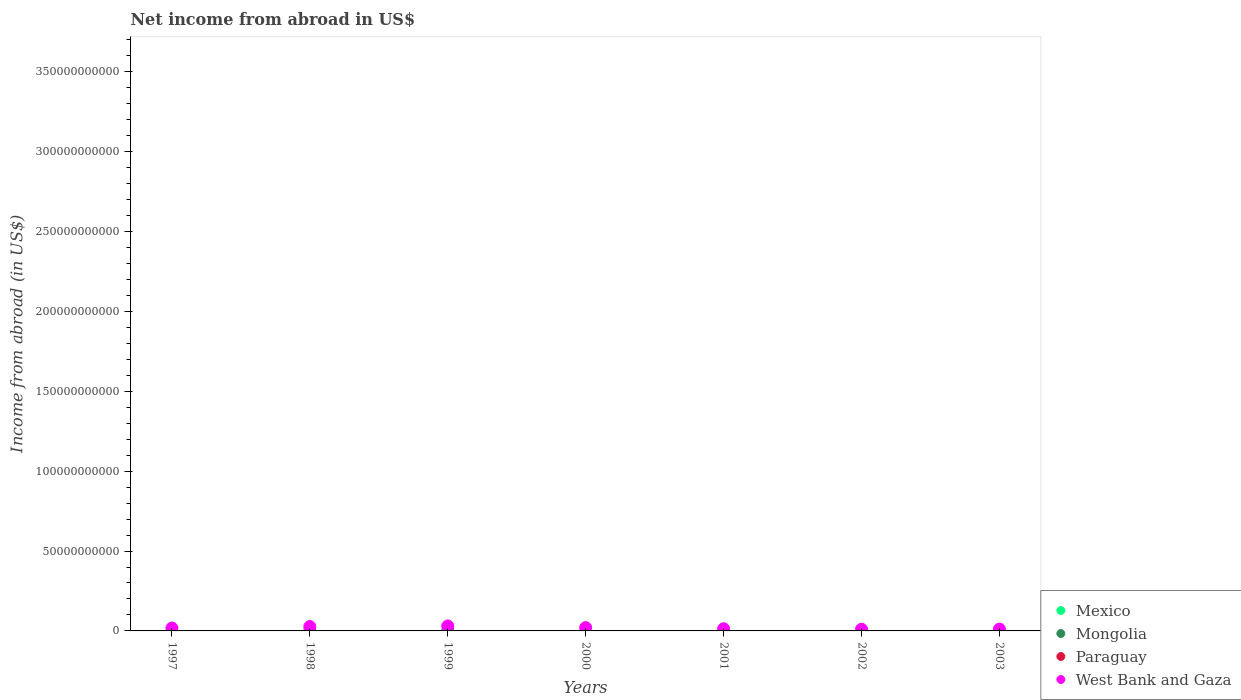What is the net income from abroad in Mexico in 1997?
Ensure brevity in your answer.  0. Across all years, what is the maximum net income from abroad in West Bank and Gaza?
Give a very brief answer. 3.12e+09. Across all years, what is the minimum net income from abroad in West Bank and Gaza?
Give a very brief answer. 1.04e+09. What is the total net income from abroad in Paraguay in the graph?
Keep it short and to the point. 0. What is the difference between the net income from abroad in West Bank and Gaza in 1998 and that in 2000?
Make the answer very short. 6.69e+08. What is the difference between the net income from abroad in West Bank and Gaza in 1999 and the net income from abroad in Mexico in 2000?
Offer a terse response. 3.12e+09. In the year 1998, what is the difference between the net income from abroad in Mongolia and net income from abroad in West Bank and Gaza?
Make the answer very short. -2.40e+09. In how many years, is the net income from abroad in West Bank and Gaza greater than 230000000000 US$?
Keep it short and to the point. 0. What is the ratio of the net income from abroad in West Bank and Gaza in 1997 to that in 2003?
Make the answer very short. 1.62. Is the net income from abroad in West Bank and Gaza in 1999 less than that in 2003?
Make the answer very short. No. What is the difference between the highest and the second highest net income from abroad in West Bank and Gaza?
Offer a very short reply. 3.90e+08. What is the difference between the highest and the lowest net income from abroad in West Bank and Gaza?
Provide a short and direct response. 2.08e+09. Is it the case that in every year, the sum of the net income from abroad in West Bank and Gaza and net income from abroad in Mexico  is greater than the sum of net income from abroad in Paraguay and net income from abroad in Mongolia?
Your answer should be compact. No. Is it the case that in every year, the sum of the net income from abroad in West Bank and Gaza and net income from abroad in Mexico  is greater than the net income from abroad in Mongolia?
Keep it short and to the point. Yes. Does the net income from abroad in Paraguay monotonically increase over the years?
Keep it short and to the point. No. Is the net income from abroad in Paraguay strictly greater than the net income from abroad in West Bank and Gaza over the years?
Your answer should be compact. No. What is the difference between two consecutive major ticks on the Y-axis?
Ensure brevity in your answer.  5.00e+1. Are the values on the major ticks of Y-axis written in scientific E-notation?
Your answer should be very brief. No. Does the graph contain any zero values?
Provide a succinct answer. Yes. Where does the legend appear in the graph?
Offer a very short reply. Bottom right. How many legend labels are there?
Keep it short and to the point. 4. How are the legend labels stacked?
Provide a succinct answer. Vertical. What is the title of the graph?
Ensure brevity in your answer.  Net income from abroad in US$. What is the label or title of the Y-axis?
Offer a terse response. Income from abroad (in US$). What is the Income from abroad (in US$) in Mongolia in 1997?
Keep it short and to the point. 0. What is the Income from abroad (in US$) of West Bank and Gaza in 1997?
Give a very brief answer. 1.80e+09. What is the Income from abroad (in US$) of Mexico in 1998?
Your answer should be compact. 0. What is the Income from abroad (in US$) in Mongolia in 1998?
Provide a short and direct response. 3.36e+08. What is the Income from abroad (in US$) in Paraguay in 1998?
Give a very brief answer. 0. What is the Income from abroad (in US$) of West Bank and Gaza in 1998?
Your answer should be very brief. 2.73e+09. What is the Income from abroad (in US$) of Mexico in 1999?
Provide a succinct answer. 0. What is the Income from abroad (in US$) of Mongolia in 1999?
Your response must be concise. 1.02e+08. What is the Income from abroad (in US$) in Paraguay in 1999?
Ensure brevity in your answer.  0. What is the Income from abroad (in US$) of West Bank and Gaza in 1999?
Provide a short and direct response. 3.12e+09. What is the Income from abroad (in US$) in Mexico in 2000?
Your answer should be very brief. 0. What is the Income from abroad (in US$) of Mongolia in 2000?
Ensure brevity in your answer.  0. What is the Income from abroad (in US$) in West Bank and Gaza in 2000?
Your response must be concise. 2.06e+09. What is the Income from abroad (in US$) of Mexico in 2001?
Your answer should be compact. 0. What is the Income from abroad (in US$) of West Bank and Gaza in 2001?
Make the answer very short. 1.34e+09. What is the Income from abroad (in US$) in Mexico in 2002?
Offer a terse response. 0. What is the Income from abroad (in US$) of West Bank and Gaza in 2002?
Offer a very short reply. 1.04e+09. What is the Income from abroad (in US$) in Mexico in 2003?
Your response must be concise. 0. What is the Income from abroad (in US$) in Mongolia in 2003?
Your answer should be compact. 0. What is the Income from abroad (in US$) in Paraguay in 2003?
Provide a succinct answer. 0. What is the Income from abroad (in US$) of West Bank and Gaza in 2003?
Give a very brief answer. 1.11e+09. Across all years, what is the maximum Income from abroad (in US$) in Mongolia?
Ensure brevity in your answer.  3.36e+08. Across all years, what is the maximum Income from abroad (in US$) of West Bank and Gaza?
Your answer should be very brief. 3.12e+09. Across all years, what is the minimum Income from abroad (in US$) in Mongolia?
Offer a terse response. 0. Across all years, what is the minimum Income from abroad (in US$) of West Bank and Gaza?
Make the answer very short. 1.04e+09. What is the total Income from abroad (in US$) in Mongolia in the graph?
Provide a short and direct response. 4.38e+08. What is the total Income from abroad (in US$) in Paraguay in the graph?
Ensure brevity in your answer.  0. What is the total Income from abroad (in US$) in West Bank and Gaza in the graph?
Your answer should be compact. 1.32e+1. What is the difference between the Income from abroad (in US$) in West Bank and Gaza in 1997 and that in 1998?
Give a very brief answer. -9.36e+08. What is the difference between the Income from abroad (in US$) of West Bank and Gaza in 1997 and that in 1999?
Make the answer very short. -1.33e+09. What is the difference between the Income from abroad (in US$) in West Bank and Gaza in 1997 and that in 2000?
Offer a terse response. -2.67e+08. What is the difference between the Income from abroad (in US$) of West Bank and Gaza in 1997 and that in 2001?
Your answer should be compact. 4.52e+08. What is the difference between the Income from abroad (in US$) of West Bank and Gaza in 1997 and that in 2002?
Make the answer very short. 7.57e+08. What is the difference between the Income from abroad (in US$) of West Bank and Gaza in 1997 and that in 2003?
Offer a terse response. 6.84e+08. What is the difference between the Income from abroad (in US$) in Mongolia in 1998 and that in 1999?
Your response must be concise. 2.34e+08. What is the difference between the Income from abroad (in US$) of West Bank and Gaza in 1998 and that in 1999?
Your answer should be very brief. -3.90e+08. What is the difference between the Income from abroad (in US$) of West Bank and Gaza in 1998 and that in 2000?
Provide a succinct answer. 6.69e+08. What is the difference between the Income from abroad (in US$) in West Bank and Gaza in 1998 and that in 2001?
Make the answer very short. 1.39e+09. What is the difference between the Income from abroad (in US$) of West Bank and Gaza in 1998 and that in 2002?
Your response must be concise. 1.69e+09. What is the difference between the Income from abroad (in US$) in West Bank and Gaza in 1998 and that in 2003?
Provide a short and direct response. 1.62e+09. What is the difference between the Income from abroad (in US$) in West Bank and Gaza in 1999 and that in 2000?
Offer a terse response. 1.06e+09. What is the difference between the Income from abroad (in US$) in West Bank and Gaza in 1999 and that in 2001?
Offer a very short reply. 1.78e+09. What is the difference between the Income from abroad (in US$) in West Bank and Gaza in 1999 and that in 2002?
Your answer should be very brief. 2.08e+09. What is the difference between the Income from abroad (in US$) of West Bank and Gaza in 1999 and that in 2003?
Your answer should be very brief. 2.01e+09. What is the difference between the Income from abroad (in US$) in West Bank and Gaza in 2000 and that in 2001?
Your answer should be very brief. 7.19e+08. What is the difference between the Income from abroad (in US$) of West Bank and Gaza in 2000 and that in 2002?
Make the answer very short. 1.02e+09. What is the difference between the Income from abroad (in US$) of West Bank and Gaza in 2000 and that in 2003?
Give a very brief answer. 9.52e+08. What is the difference between the Income from abroad (in US$) in West Bank and Gaza in 2001 and that in 2002?
Your response must be concise. 3.05e+08. What is the difference between the Income from abroad (in US$) in West Bank and Gaza in 2001 and that in 2003?
Provide a succinct answer. 2.32e+08. What is the difference between the Income from abroad (in US$) in West Bank and Gaza in 2002 and that in 2003?
Offer a terse response. -7.34e+07. What is the difference between the Income from abroad (in US$) of Mongolia in 1998 and the Income from abroad (in US$) of West Bank and Gaza in 1999?
Provide a short and direct response. -2.78e+09. What is the difference between the Income from abroad (in US$) in Mongolia in 1998 and the Income from abroad (in US$) in West Bank and Gaza in 2000?
Your response must be concise. -1.73e+09. What is the difference between the Income from abroad (in US$) in Mongolia in 1998 and the Income from abroad (in US$) in West Bank and Gaza in 2001?
Make the answer very short. -1.01e+09. What is the difference between the Income from abroad (in US$) of Mongolia in 1998 and the Income from abroad (in US$) of West Bank and Gaza in 2002?
Your response must be concise. -7.02e+08. What is the difference between the Income from abroad (in US$) in Mongolia in 1998 and the Income from abroad (in US$) in West Bank and Gaza in 2003?
Make the answer very short. -7.75e+08. What is the difference between the Income from abroad (in US$) of Mongolia in 1999 and the Income from abroad (in US$) of West Bank and Gaza in 2000?
Your answer should be compact. -1.96e+09. What is the difference between the Income from abroad (in US$) of Mongolia in 1999 and the Income from abroad (in US$) of West Bank and Gaza in 2001?
Your answer should be compact. -1.24e+09. What is the difference between the Income from abroad (in US$) in Mongolia in 1999 and the Income from abroad (in US$) in West Bank and Gaza in 2002?
Give a very brief answer. -9.35e+08. What is the difference between the Income from abroad (in US$) in Mongolia in 1999 and the Income from abroad (in US$) in West Bank and Gaza in 2003?
Make the answer very short. -1.01e+09. What is the average Income from abroad (in US$) in Mexico per year?
Provide a short and direct response. 0. What is the average Income from abroad (in US$) of Mongolia per year?
Offer a terse response. 6.26e+07. What is the average Income from abroad (in US$) of Paraguay per year?
Make the answer very short. 0. What is the average Income from abroad (in US$) in West Bank and Gaza per year?
Provide a succinct answer. 1.89e+09. In the year 1998, what is the difference between the Income from abroad (in US$) in Mongolia and Income from abroad (in US$) in West Bank and Gaza?
Offer a very short reply. -2.40e+09. In the year 1999, what is the difference between the Income from abroad (in US$) in Mongolia and Income from abroad (in US$) in West Bank and Gaza?
Your response must be concise. -3.02e+09. What is the ratio of the Income from abroad (in US$) of West Bank and Gaza in 1997 to that in 1998?
Offer a terse response. 0.66. What is the ratio of the Income from abroad (in US$) in West Bank and Gaza in 1997 to that in 1999?
Provide a succinct answer. 0.58. What is the ratio of the Income from abroad (in US$) in West Bank and Gaza in 1997 to that in 2000?
Provide a succinct answer. 0.87. What is the ratio of the Income from abroad (in US$) of West Bank and Gaza in 1997 to that in 2001?
Offer a terse response. 1.34. What is the ratio of the Income from abroad (in US$) in West Bank and Gaza in 1997 to that in 2002?
Provide a short and direct response. 1.73. What is the ratio of the Income from abroad (in US$) in West Bank and Gaza in 1997 to that in 2003?
Provide a succinct answer. 1.62. What is the ratio of the Income from abroad (in US$) of Mongolia in 1998 to that in 1999?
Your response must be concise. 3.29. What is the ratio of the Income from abroad (in US$) of West Bank and Gaza in 1998 to that in 1999?
Offer a very short reply. 0.88. What is the ratio of the Income from abroad (in US$) in West Bank and Gaza in 1998 to that in 2000?
Offer a terse response. 1.32. What is the ratio of the Income from abroad (in US$) in West Bank and Gaza in 1998 to that in 2001?
Make the answer very short. 2.03. What is the ratio of the Income from abroad (in US$) in West Bank and Gaza in 1998 to that in 2002?
Provide a short and direct response. 2.63. What is the ratio of the Income from abroad (in US$) in West Bank and Gaza in 1998 to that in 2003?
Give a very brief answer. 2.46. What is the ratio of the Income from abroad (in US$) in West Bank and Gaza in 1999 to that in 2000?
Provide a succinct answer. 1.51. What is the ratio of the Income from abroad (in US$) in West Bank and Gaza in 1999 to that in 2001?
Give a very brief answer. 2.32. What is the ratio of the Income from abroad (in US$) in West Bank and Gaza in 1999 to that in 2002?
Your answer should be very brief. 3.01. What is the ratio of the Income from abroad (in US$) in West Bank and Gaza in 1999 to that in 2003?
Provide a short and direct response. 2.81. What is the ratio of the Income from abroad (in US$) in West Bank and Gaza in 2000 to that in 2001?
Give a very brief answer. 1.54. What is the ratio of the Income from abroad (in US$) of West Bank and Gaza in 2000 to that in 2002?
Keep it short and to the point. 1.99. What is the ratio of the Income from abroad (in US$) in West Bank and Gaza in 2000 to that in 2003?
Provide a short and direct response. 1.86. What is the ratio of the Income from abroad (in US$) in West Bank and Gaza in 2001 to that in 2002?
Provide a succinct answer. 1.29. What is the ratio of the Income from abroad (in US$) in West Bank and Gaza in 2001 to that in 2003?
Keep it short and to the point. 1.21. What is the ratio of the Income from abroad (in US$) of West Bank and Gaza in 2002 to that in 2003?
Make the answer very short. 0.93. What is the difference between the highest and the second highest Income from abroad (in US$) in West Bank and Gaza?
Provide a short and direct response. 3.90e+08. What is the difference between the highest and the lowest Income from abroad (in US$) of Mongolia?
Your answer should be very brief. 3.36e+08. What is the difference between the highest and the lowest Income from abroad (in US$) in West Bank and Gaza?
Provide a succinct answer. 2.08e+09. 